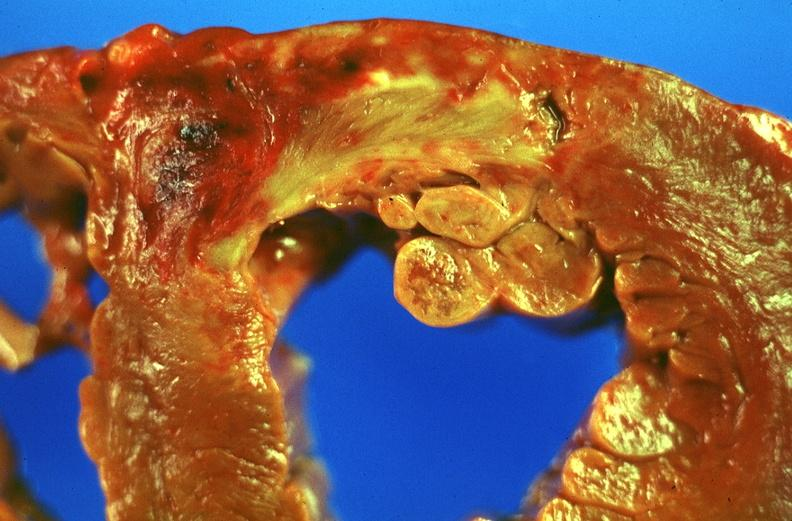does this image show acute myocardial infarction?
Answer the question using a single word or phrase. Yes 